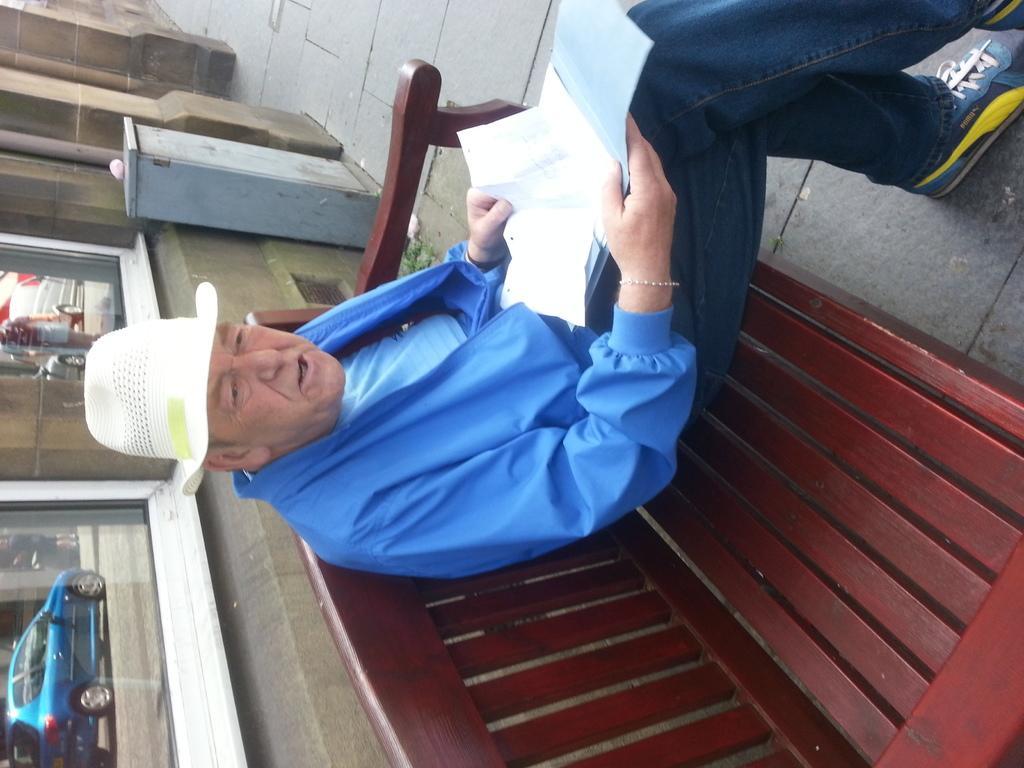Can you describe this image briefly? In this image there is a man who is sitting on the bench by holding the papers, Behind him there are glass windows. In the windows we can see the reflections of a car. There is a metal box which is attached to the wall. 